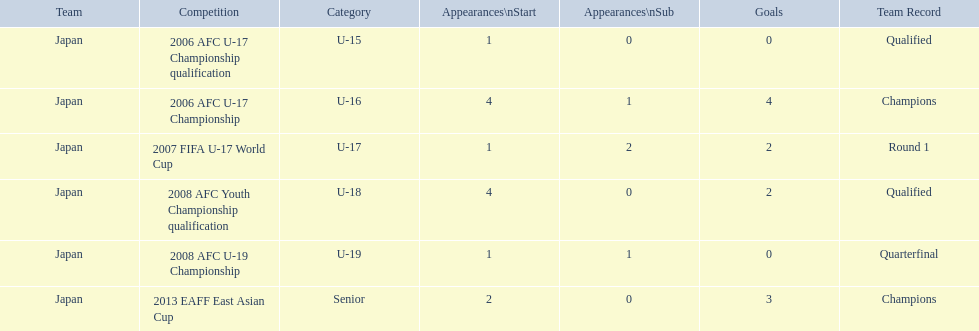What was the team record in 2006? Round 1. What competition did this belong too? 2006 AFC U-17 Championship. 